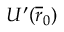<formula> <loc_0><loc_0><loc_500><loc_500>U ^ { \prime } ( \overline { r } _ { 0 } )</formula> 